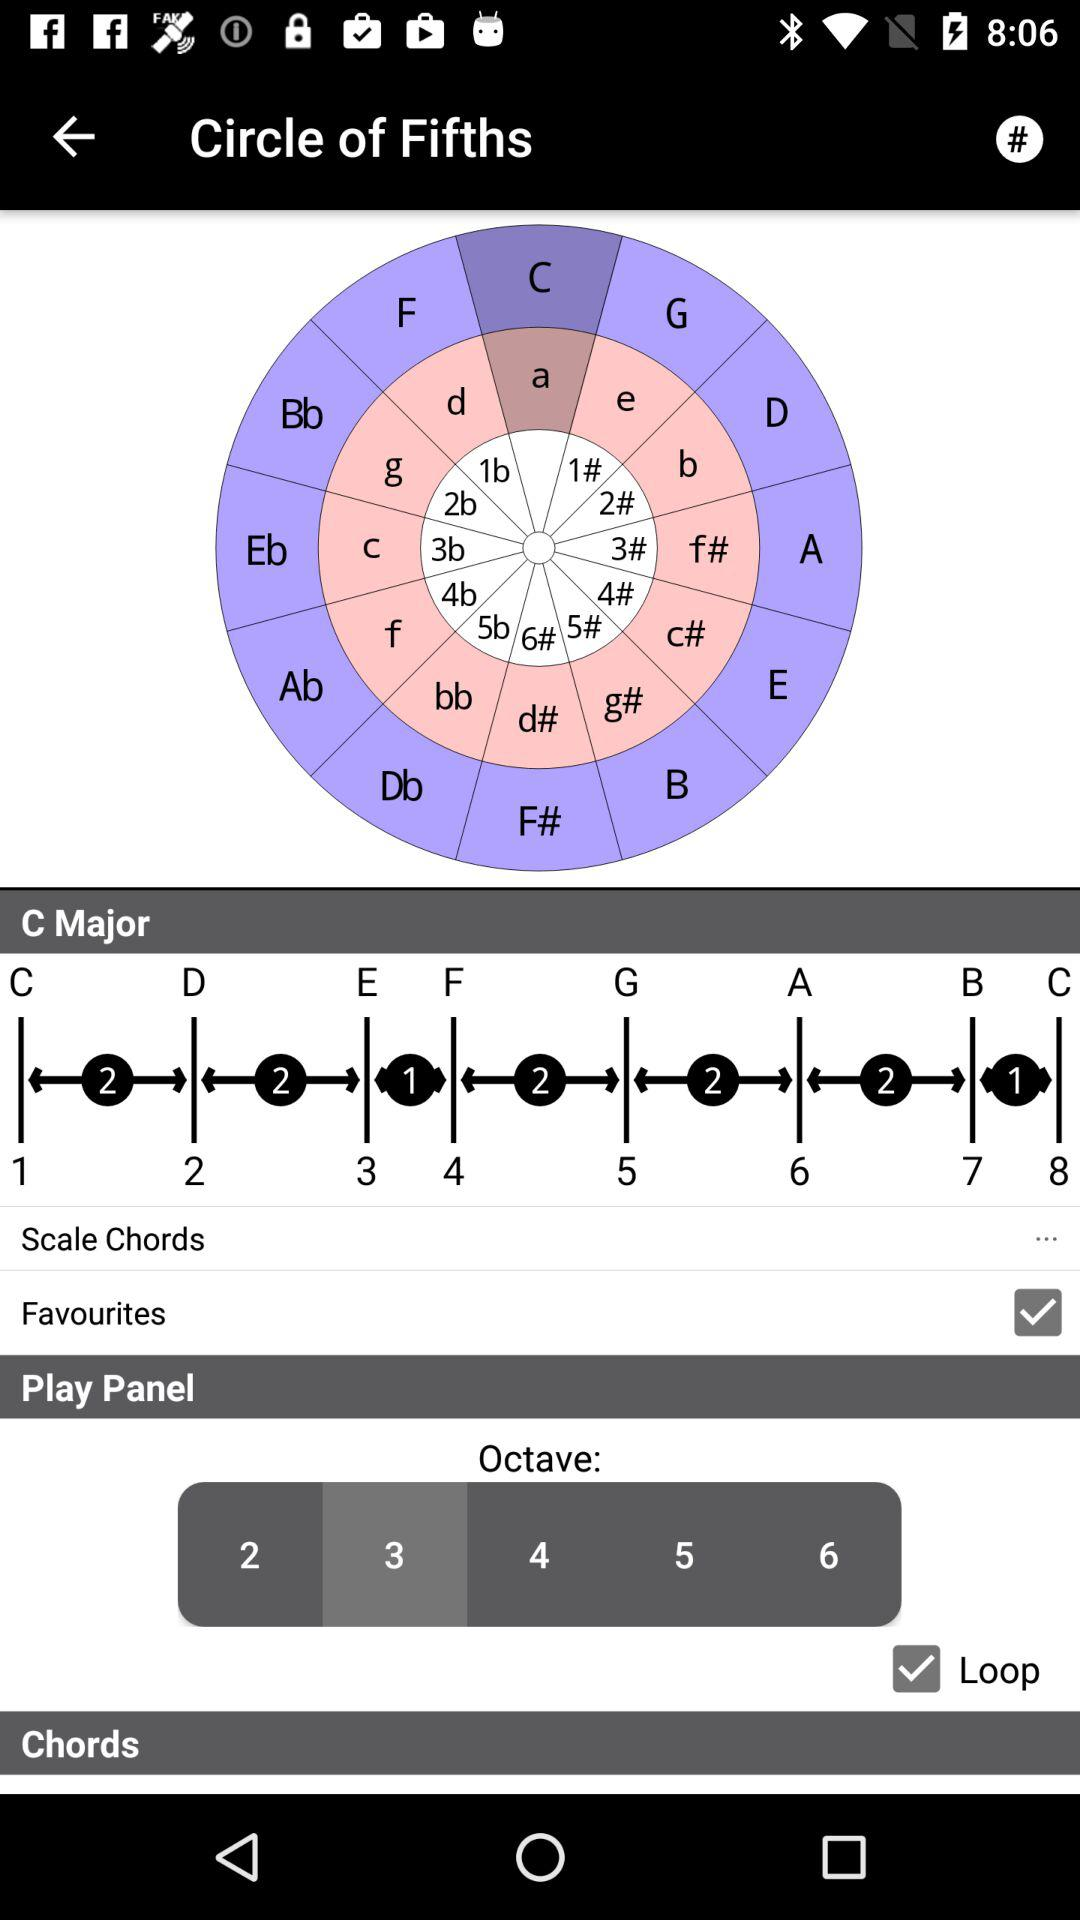What is the status of the favourites? The status of the favourites is on. 